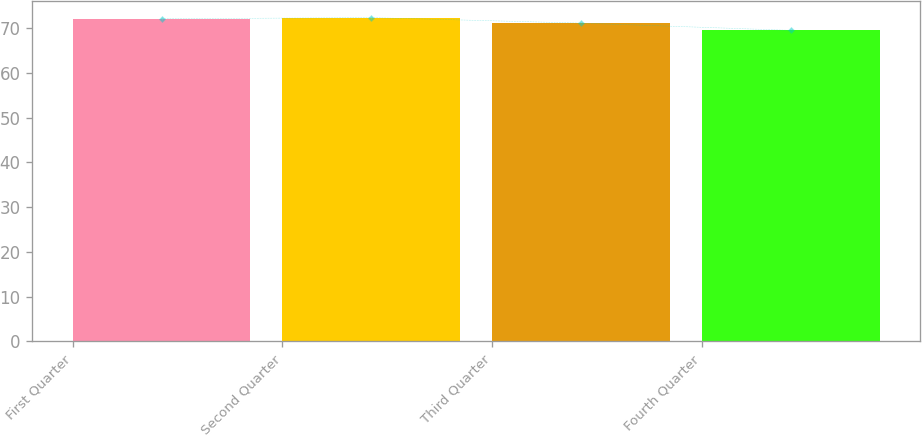Convert chart. <chart><loc_0><loc_0><loc_500><loc_500><bar_chart><fcel>First Quarter<fcel>Second Quarter<fcel>Third Quarter<fcel>Fourth Quarter<nl><fcel>72.15<fcel>72.41<fcel>71.18<fcel>69.56<nl></chart> 